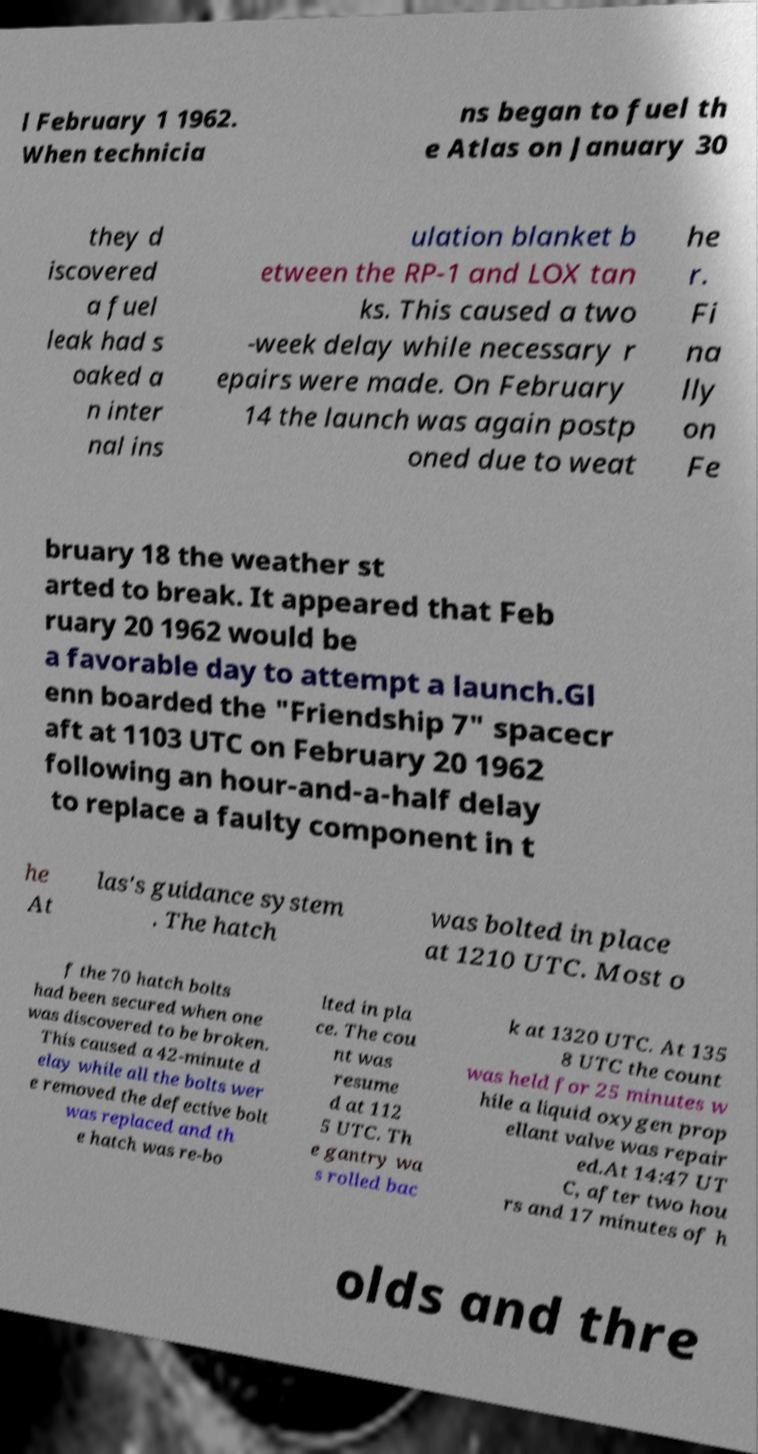For documentation purposes, I need the text within this image transcribed. Could you provide that? l February 1 1962. When technicia ns began to fuel th e Atlas on January 30 they d iscovered a fuel leak had s oaked a n inter nal ins ulation blanket b etween the RP-1 and LOX tan ks. This caused a two -week delay while necessary r epairs were made. On February 14 the launch was again postp oned due to weat he r. Fi na lly on Fe bruary 18 the weather st arted to break. It appeared that Feb ruary 20 1962 would be a favorable day to attempt a launch.Gl enn boarded the "Friendship 7" spacecr aft at 1103 UTC on February 20 1962 following an hour-and-a-half delay to replace a faulty component in t he At las's guidance system . The hatch was bolted in place at 1210 UTC. Most o f the 70 hatch bolts had been secured when one was discovered to be broken. This caused a 42-minute d elay while all the bolts wer e removed the defective bolt was replaced and th e hatch was re-bo lted in pla ce. The cou nt was resume d at 112 5 UTC. Th e gantry wa s rolled bac k at 1320 UTC. At 135 8 UTC the count was held for 25 minutes w hile a liquid oxygen prop ellant valve was repair ed.At 14:47 UT C, after two hou rs and 17 minutes of h olds and thre 